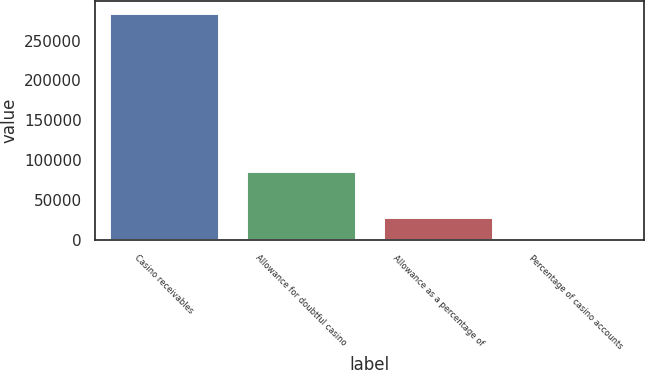Convert chart. <chart><loc_0><loc_0><loc_500><loc_500><bar_chart><fcel>Casino receivables<fcel>Allowance for doubtful casino<fcel>Allowance as a percentage of<fcel>Percentage of casino accounts<nl><fcel>285182<fcel>86010<fcel>28541.6<fcel>26<nl></chart> 